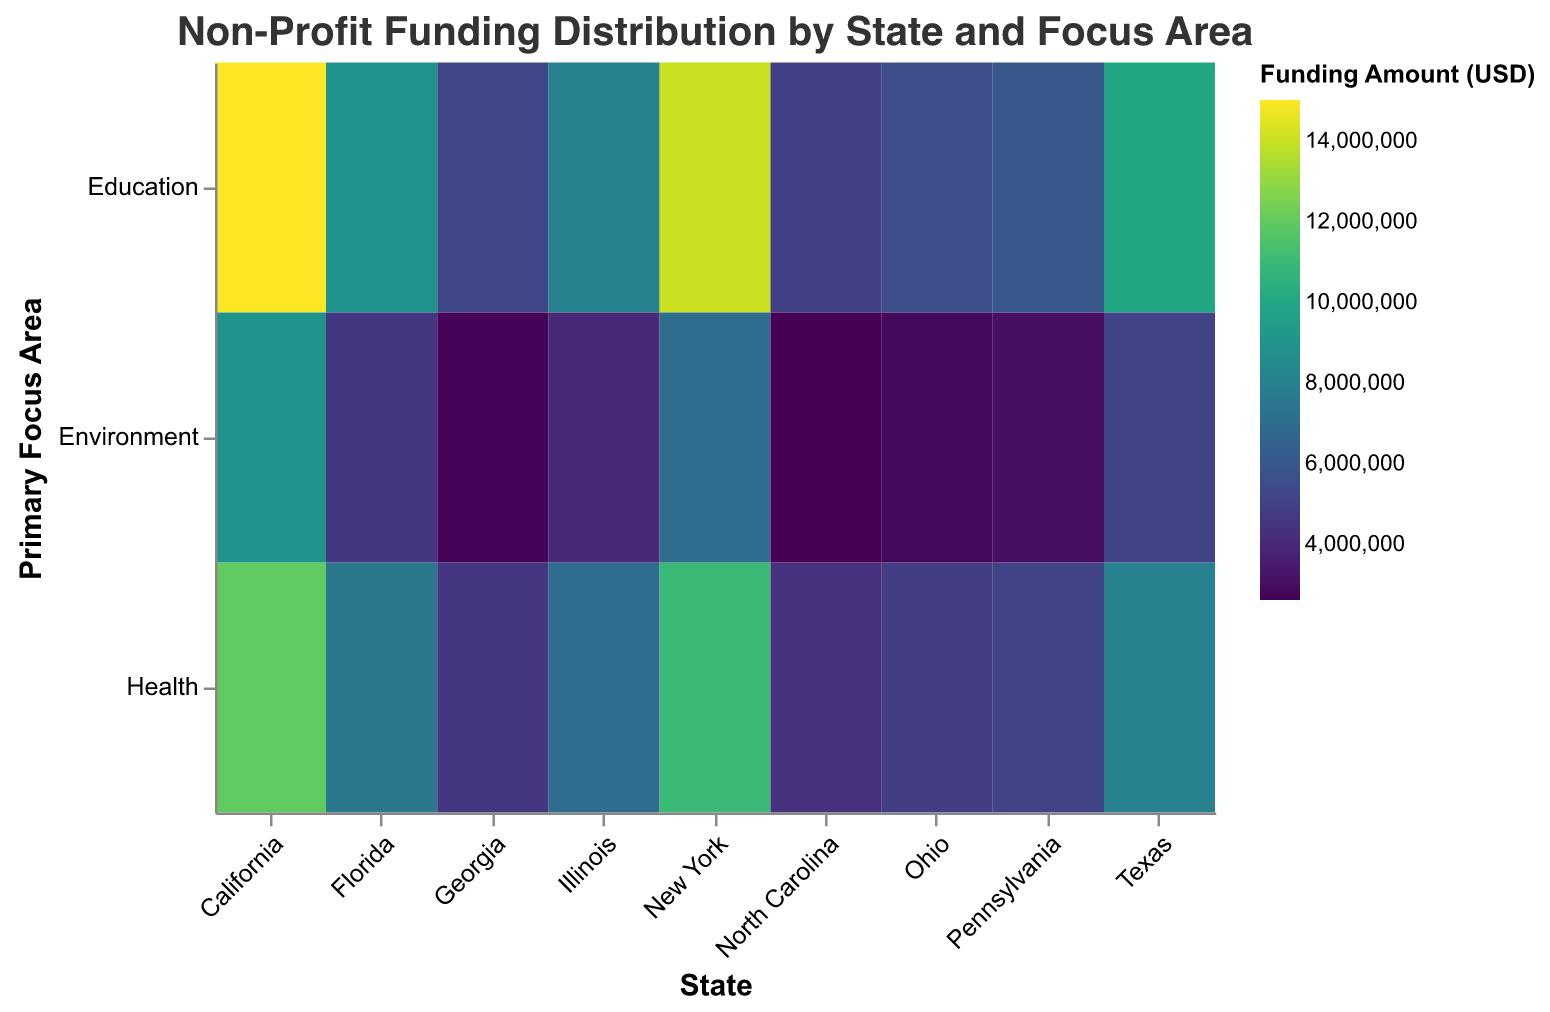What is the title of the figure? The title of the figure is located at the top and describes the overall content of the heatmap. In this case, it is "Non-Profit Funding Distribution by State and Focus Area".
Answer: Non-Profit Funding Distribution by State and Focus Area How many primary focus areas are shown in the heatmap? The heatmap includes three primary focus areas: Education, Health, and Environment. Each of these areas is represented on the y-axis.
Answer: 3 Which state has the highest funding for the Education focus area? To find the highest funding for Education, look across the Education row for the state with the darkest color. California has the highest funding amount for Education with $15,000,000.
Answer: California How does the distribution of funding for Health in New York compare to that in Texas? To compare Health funding, check the color intensity for New York and Texas in the Health row. New York (darker color) received $11,000,000, whereas Texas received $8,000,000. Thus, New York has more funding for Health than Texas.
Answer: New York has more funding for Health What is the total funding amount for Pennsylvania across all focus areas? Sum the funding amounts for Pennsylvania across Education, Health, and Environment: $6,000,000 (Education) + $5,000,000 (Health) + $3,000,000 (Environment) = $14,000,000.
Answer: $14,000,000 Which state has the least funding for the Environment focus area? In the Environment column, the least intense (lightest) color indicates the lowest funding. North Carolina has the lowest funding for the Environment focus area with $2,600,000.
Answer: North Carolina What is the average funding amount for the Education focus area across all states? List the Education funding amounts for all states and calculate the average: ($15,000,000 + $10,000,000 + $14,000,000 + $9,000,000 + $8,000,000 + $6,000,000 + $5,500,000 + $5,200,000 + $4,900,000) / 9 ≈ $8,955,556.
Answer: $8,955,556 Compare the funding distribution for Education and Health in California, which focus area receives more funding? Look at the Education and Health values for California: $15,000,000 (Education) and $12,000,000 (Health). Therefore, Education receives more funding than Health in California.
Answer: Education receives more funding Which state has the most balanced funding distribution across all focus areas? Find a state where the funding amounts for Education, Health, and Environment are most similar. Illinois, for instance, has amounts of $8,000,000, $7,000,000, and $4,000,000 respectively, indicating a relatively balanced distribution.
Answer: Illinois 